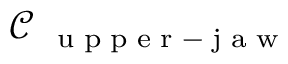<formula> <loc_0><loc_0><loc_500><loc_500>\mathcal { C } _ { u p p e r - j a w }</formula> 